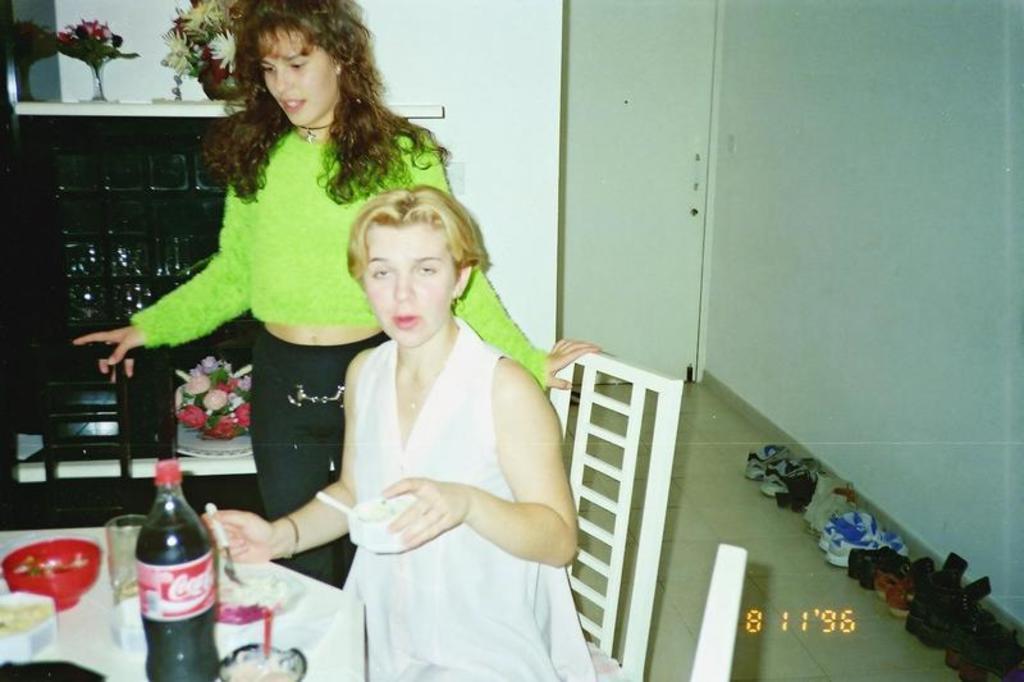Can you describe this image briefly? In this image, we can see 2 human beings. On e is sat on the chair and other is standing. And the left side bottom, we can see white table, few items are placed on it. Right side, so many footwear's are placed. Here we can see white wall, white door. And the background, there is a table,few items and flowers are placed on it. 